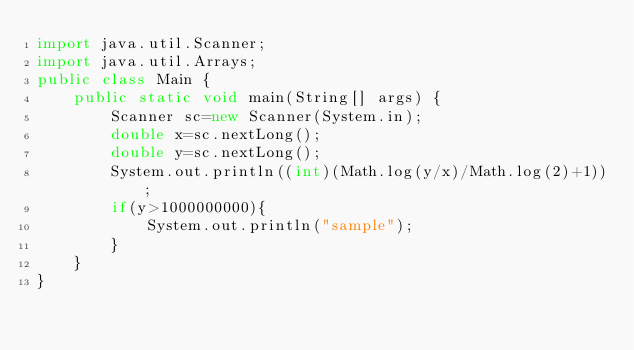Convert code to text. <code><loc_0><loc_0><loc_500><loc_500><_Java_>import java.util.Scanner;
import java.util.Arrays;
public class Main {
    public static void main(String[] args) {
        Scanner sc=new Scanner(System.in);
        double x=sc.nextLong();
        double y=sc.nextLong();
        System.out.println((int)(Math.log(y/x)/Math.log(2)+1));
        if(y>1000000000){
            System.out.println("sample");
        }
    }
}</code> 